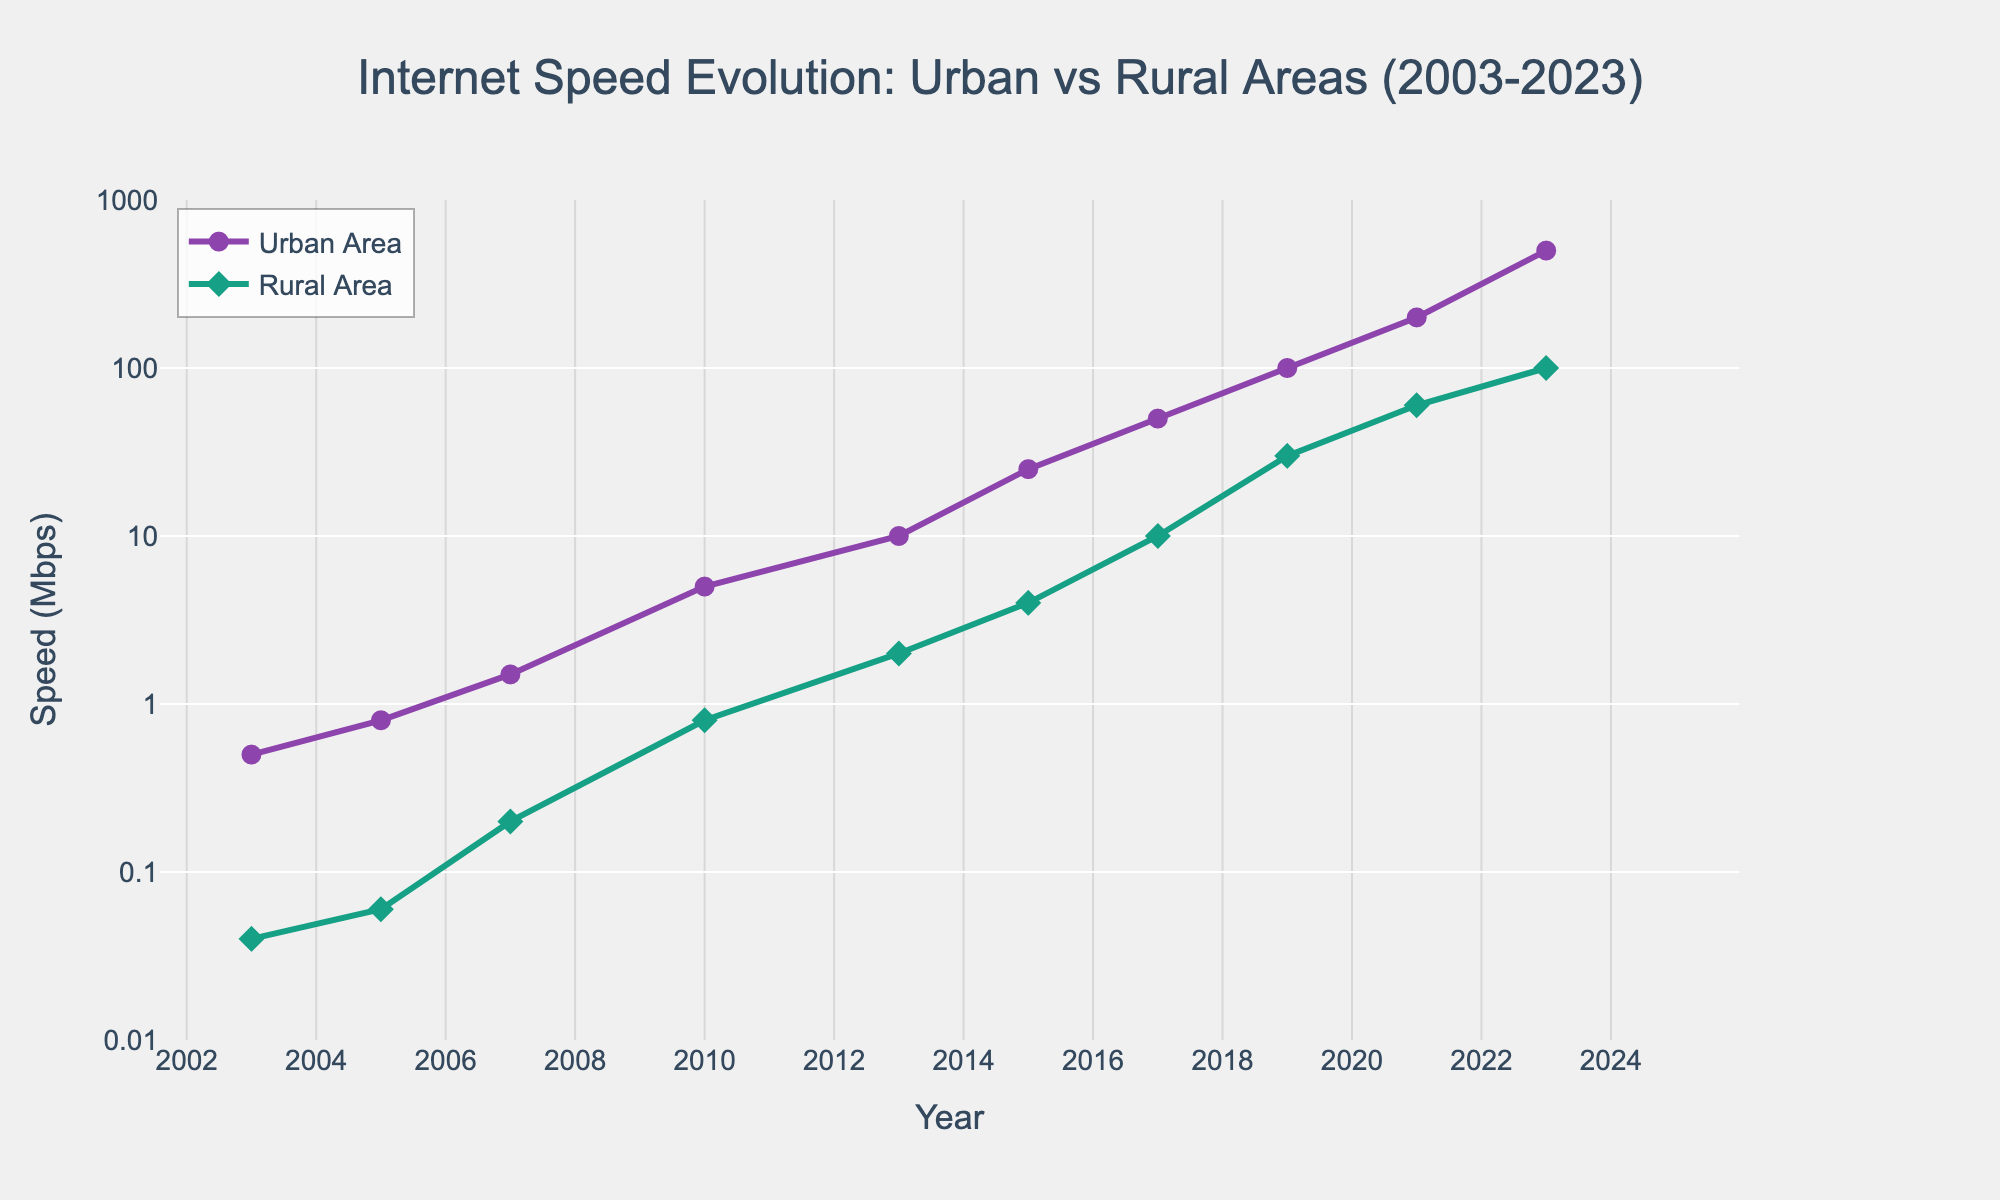What is the title of the plot? The title is provided at the top of the figure, clearly stating the focus of the plot.
Answer: "Internet Speed Evolution: Urban vs Rural Areas (2003-2023)" How many data points are shown for both urban and rural areas? Each year from 2003 to 2023 has corresponding data points for both urban and rural areas, which can be counted.
Answer: 10 What is the speed of the internet in urban areas in 2013? Find the year 2013 on the x-axis and read the corresponding y-value for the urban area (purple line).
Answer: 10 Mbps How does the rural area internet speed in 2007 compare to its speed in 2010? Locate the data points for rural area internet speed in 2007 and 2010 on the y-axis and compare the values.
Answer: 0.2 Mbps in 2007 and 0.8 Mbps in 2010; it increased Which year saw urban areas reach 500 Mbps? Check the annotation on the plot indicating that urban areas reached 500 Mbps.
Answer: 2023 What is the internet speed ratio of urban to rural areas in 2023? Divide the urban internet speed by the rural internet speed for 2023: 500 Mbps / 100 Mbps.
Answer: 5 When did rural areas first achieve a speed of 10 Mbps? Trace along the green line for rural areas until it first reaches the y-value of 10 Mbps.
Answer: 2017 By how much did the urban internet speed increase from 2003 to 2023? Subtract the 2003 urban speed from the 2023 urban speed: 500 Mbps - 0.5 Mbps.
Answer: 499.5 Mbps Is the growth trend in internet speed for rural areas generally increasing or decreasing over the years shown? Observe the overall direction of the rural area speed line from 2003 to 2023.
Answer: Increasing Based on the plot, which location saw a higher absolute increase in internet speed from 2003 to 2023, urban or rural areas? Calculate the difference in internet speeds for both areas from 2003 to 2023 and compare. Urban: 500 - 0.5 = 499.5 Mbps; Rural: 100 - 0.04 = 99.96 Mbps.
Answer: Urban areas How much faster is the internet speed in urban areas compared to rural areas in 2019? Subtract the rural speed from the urban speed for 2019: 100 - 30.
Answer: 70 Mbps 